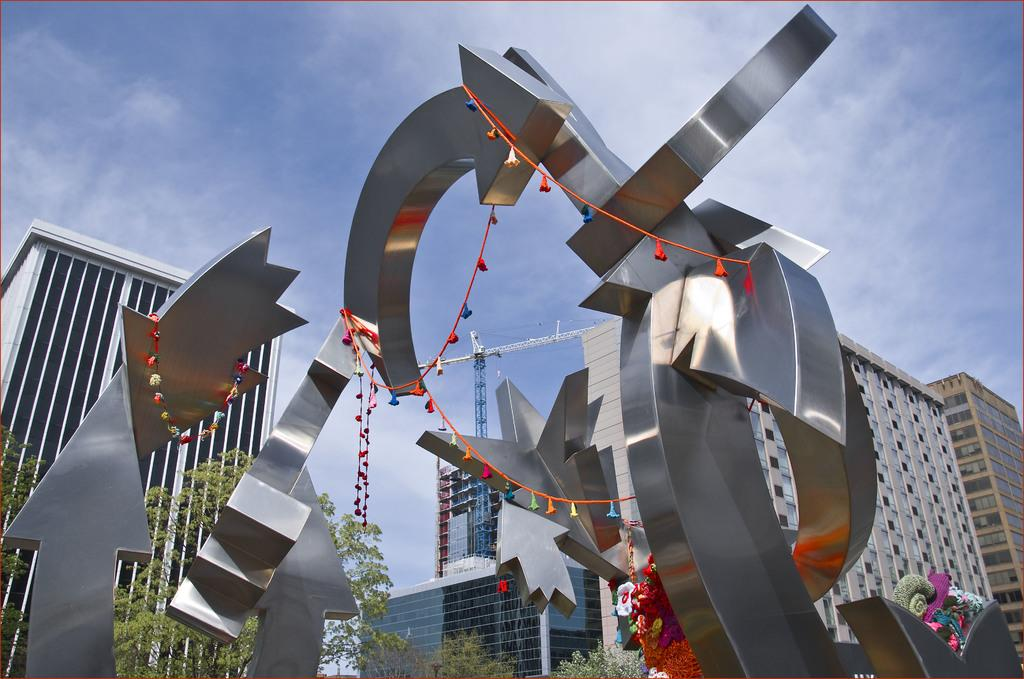What is the main subject in the foreground of the image? There is a design structure in the foreground of the image. What can be seen in the background of the image? There are buildings and trees in the background of the image. What is visible at the top of the image? The sky is visible at the top of the image. How many jellyfish are swimming in the sky in the image? There are no jellyfish present in the image, and they cannot swim in the sky. 